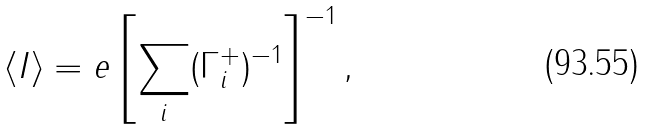<formula> <loc_0><loc_0><loc_500><loc_500>\langle I \rangle = e \left [ \sum _ { i } ( \Gamma _ { i } ^ { + } ) ^ { - 1 } \right ] ^ { - 1 } ,</formula> 